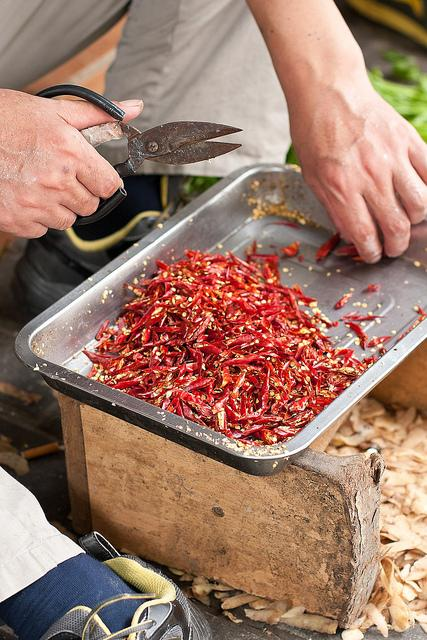Which is widely used in many cuisines as a spice to add pungent 'heat' to dishes? peppers 